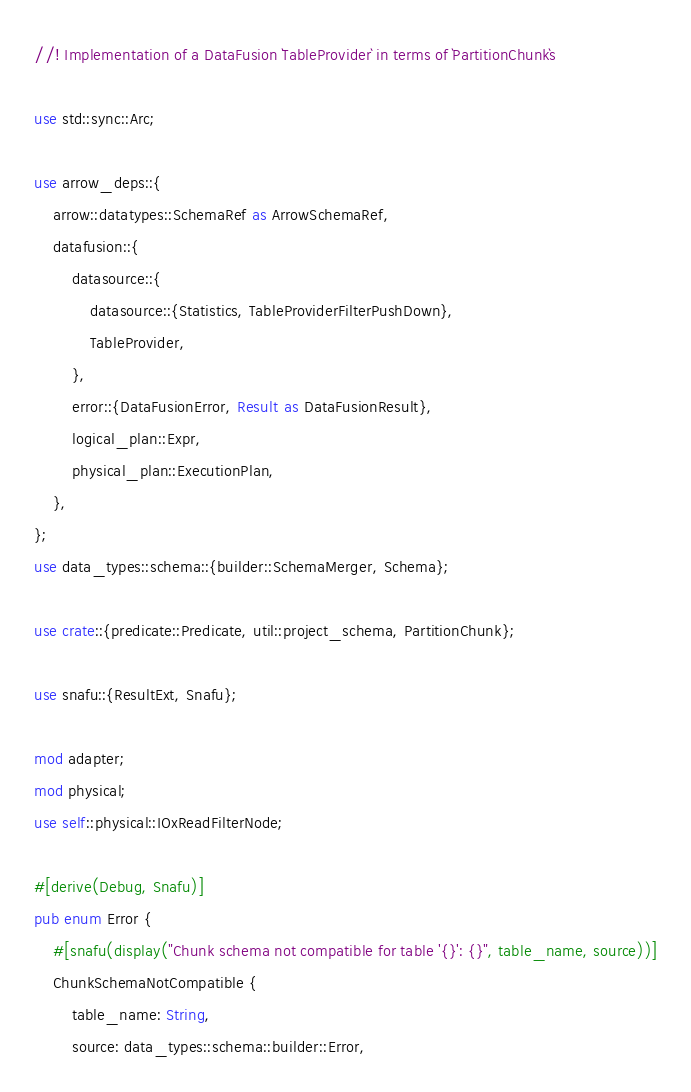<code> <loc_0><loc_0><loc_500><loc_500><_Rust_>//! Implementation of a DataFusion `TableProvider` in terms of `PartitionChunk`s

use std::sync::Arc;

use arrow_deps::{
    arrow::datatypes::SchemaRef as ArrowSchemaRef,
    datafusion::{
        datasource::{
            datasource::{Statistics, TableProviderFilterPushDown},
            TableProvider,
        },
        error::{DataFusionError, Result as DataFusionResult},
        logical_plan::Expr,
        physical_plan::ExecutionPlan,
    },
};
use data_types::schema::{builder::SchemaMerger, Schema};

use crate::{predicate::Predicate, util::project_schema, PartitionChunk};

use snafu::{ResultExt, Snafu};

mod adapter;
mod physical;
use self::physical::IOxReadFilterNode;

#[derive(Debug, Snafu)]
pub enum Error {
    #[snafu(display("Chunk schema not compatible for table '{}': {}", table_name, source))]
    ChunkSchemaNotCompatible {
        table_name: String,
        source: data_types::schema::builder::Error,</code> 